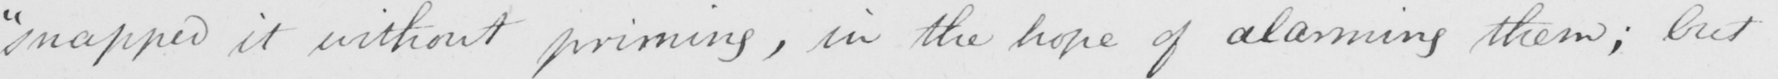What is written in this line of handwriting? " snapped it without priming , in the hope of alarming them ; but 